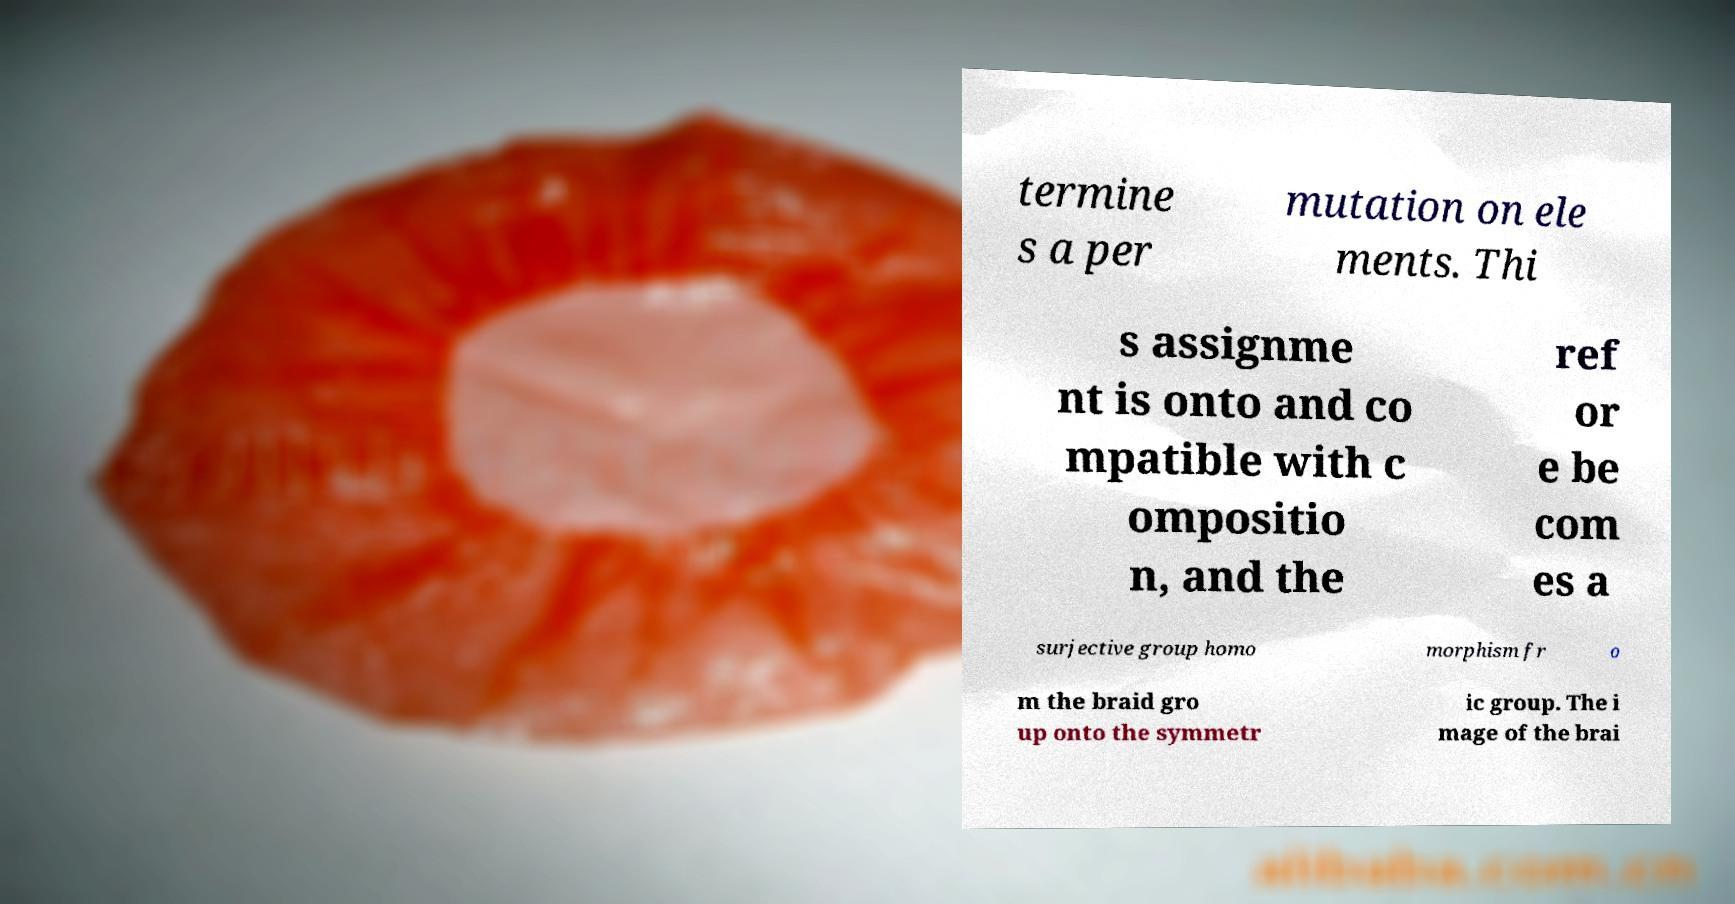There's text embedded in this image that I need extracted. Can you transcribe it verbatim? termine s a per mutation on ele ments. Thi s assignme nt is onto and co mpatible with c ompositio n, and the ref or e be com es a surjective group homo morphism fr o m the braid gro up onto the symmetr ic group. The i mage of the brai 